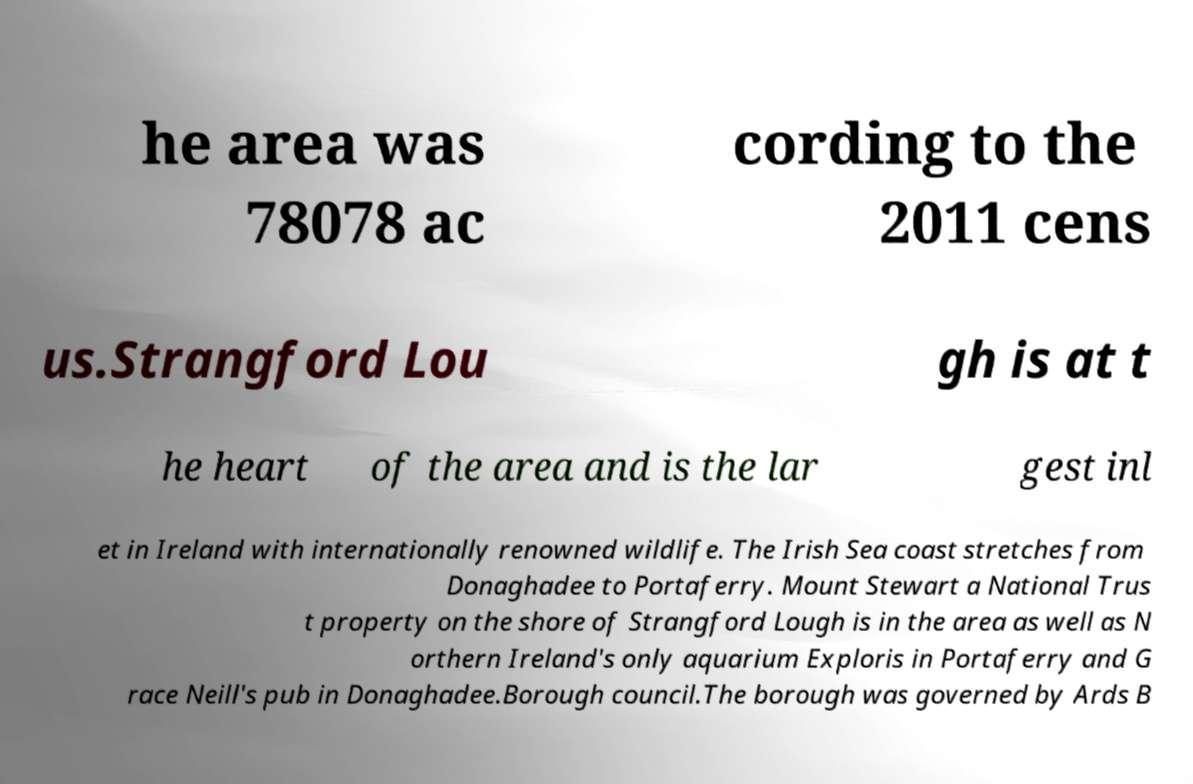Could you extract and type out the text from this image? he area was 78078 ac cording to the 2011 cens us.Strangford Lou gh is at t he heart of the area and is the lar gest inl et in Ireland with internationally renowned wildlife. The Irish Sea coast stretches from Donaghadee to Portaferry. Mount Stewart a National Trus t property on the shore of Strangford Lough is in the area as well as N orthern Ireland's only aquarium Exploris in Portaferry and G race Neill's pub in Donaghadee.Borough council.The borough was governed by Ards B 